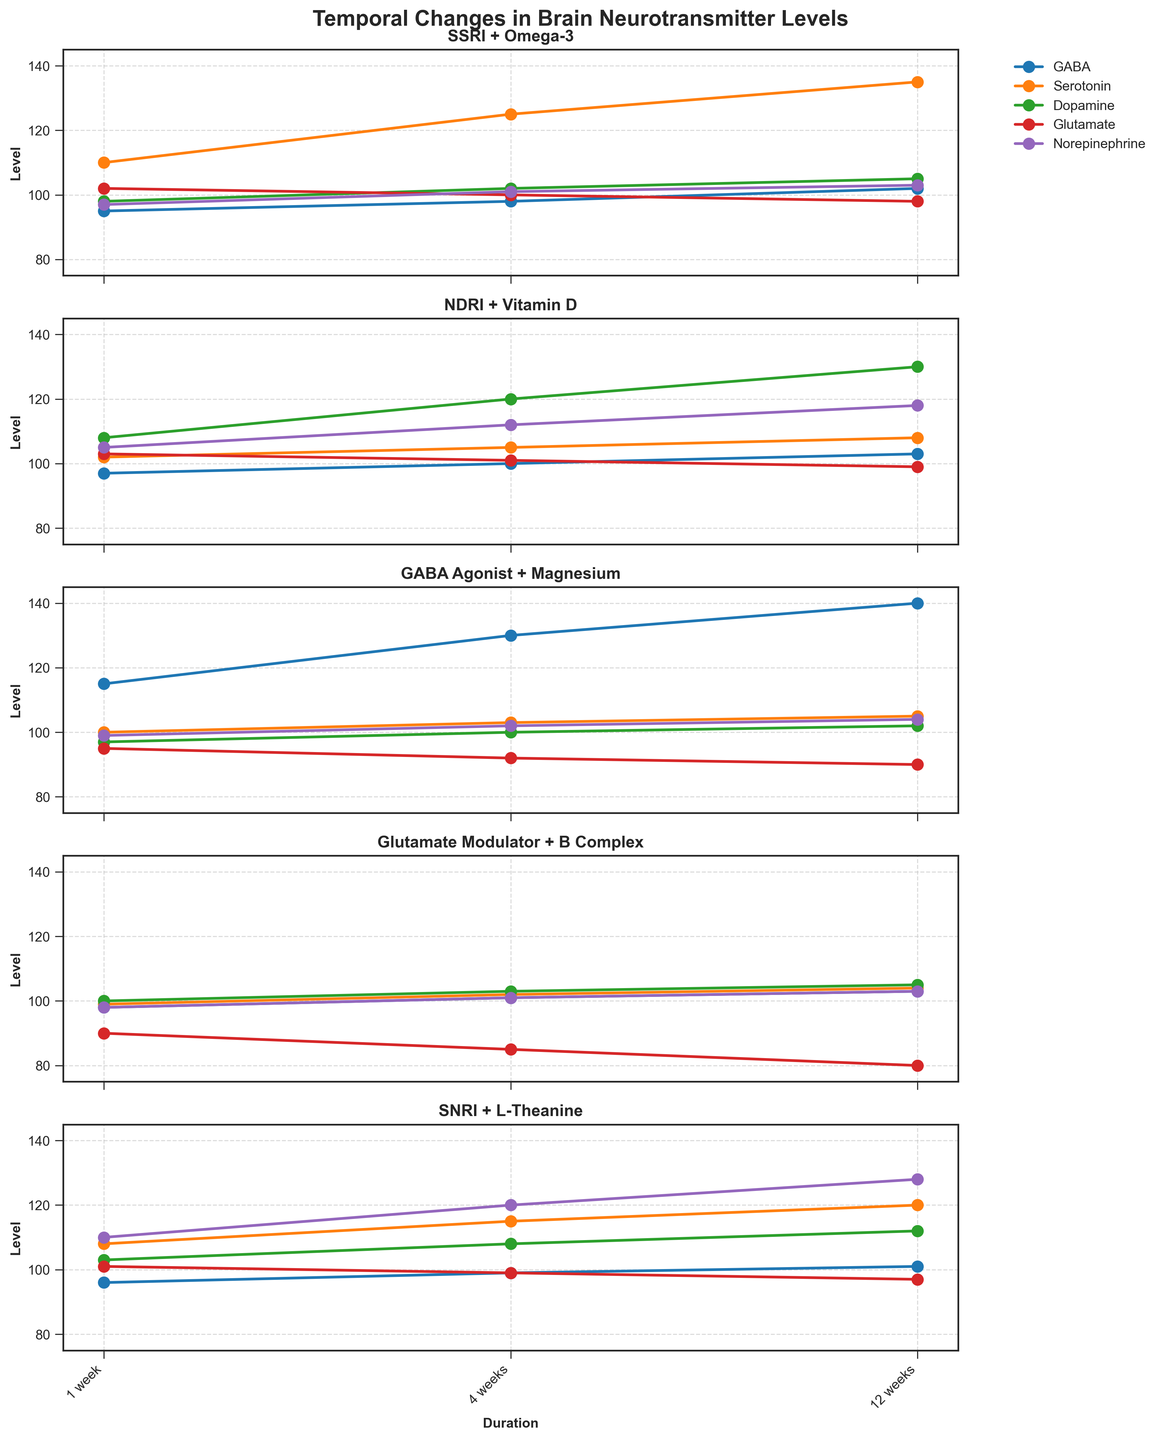What is the title of the figure? The title is prominently displayed at the top of the figure in bold font. It helps viewers quickly understand the subject of the plot.
Answer: Temporal Changes in Brain Neurotransmitter Levels How many neurotransmitters are tracked in each intervention? Each line on the individual intervention plots represents a distinct neurotransmitter. Counting the lines will give the number of neurotransmitters tracked.
Answer: Five Which intervention shows the highest GABA level at 12 weeks? Look for the peak GABA values across all intervention plots at the 12-week mark. Identify the highest value and the corresponding intervention.
Answer: GABA Agonist + Magnesium How does dopamine change over 12 weeks for SSRI + Omega-3? Focus on the plot for SSRI + Omega-3. Track the dopamine levels (marked with appropriate symbols) across the three durations (1 week, 4 weeks, 12 weeks).
Answer: Starts at 98, then 102, and finally 105 At 4 weeks, which intervention has the highest norepinephrine level? Navigate through all plots and identify the 4-week markers for norepinephrine. Compare the values to see which is the highest.
Answer: SNRI + L-Theanine What is the trend of serotonin levels for NDRI + Vitamin D over the treatment durations? Examine the serotonin line in the NDRi + Vitamin D plot. Note the values at 1 week, 4 weeks, and 12 weeks to determine the overall trend.
Answer: Increasing trend (102, 105, 108) Compare the glutamate levels between SSRI + Omega-3 and Glutamate Modulator + B Complex at all durations. Which intervention shows a greater decrease? Compare the actual numerical changes of glutamate levels from the beginning to the end of treatment for both interventions.
Answer: Glutamate Modulator + B Complex shows a greater decrease How does norepinephrine vary in the SNRI + L-Theanine intervention? Check the norepinephrine line in the SNRI + L-Theanine plot and list the values at all three durations (1 week, 4 weeks, 12 weeks).
Answer: Starts at 110, then 120, and finally 128 Which intervention has the smallest change in serotonin levels over the 12-week period? Track the serotonin levels for each intervention plot across the three treatment durations and calculate the changes.
Answer: Glutamate Modulator + B Complex What is the average level of dopamine for NDRI + Vitamin D intervention over 12 weeks? Add the dopamine levels for the three different durations in NDRI + Vitamin D and divide by 3 to get the average.
Answer: (108+120+130)/3 = 119 